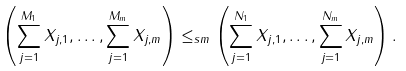<formula> <loc_0><loc_0><loc_500><loc_500>\left ( \sum _ { j = 1 } ^ { M _ { 1 } } X _ { j , 1 } , \dots , \sum _ { j = 1 } ^ { M _ { m } } X _ { j , m } \right ) \leq _ { s m } \left ( \sum _ { j = 1 } ^ { N _ { 1 } } X _ { j , 1 } , \dots , \sum _ { j = 1 } ^ { N _ { m } } X _ { j , m } \right ) .</formula> 